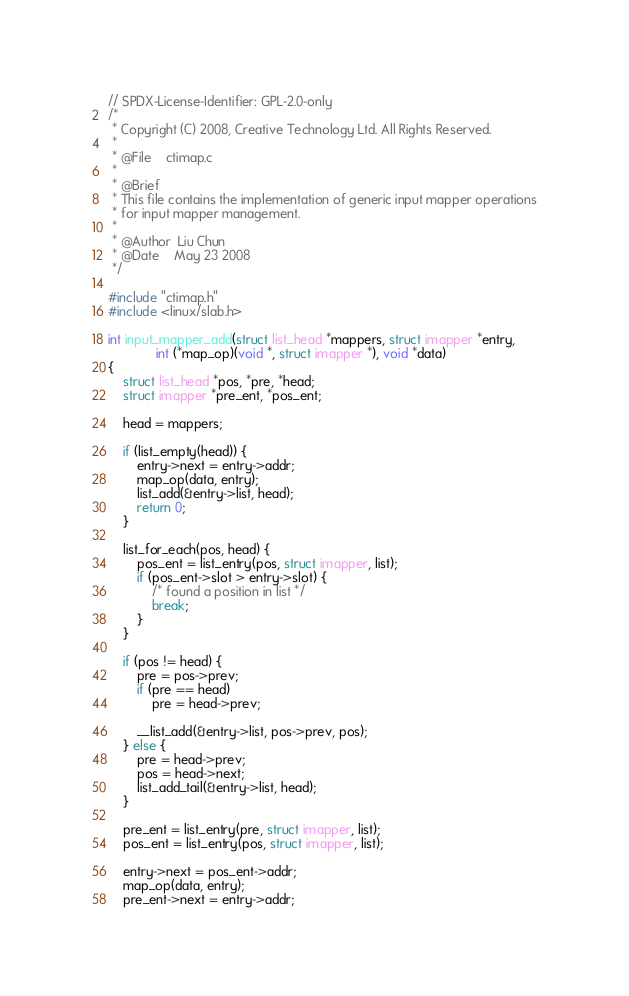Convert code to text. <code><loc_0><loc_0><loc_500><loc_500><_C_>// SPDX-License-Identifier: GPL-2.0-only
/*
 * Copyright (C) 2008, Creative Technology Ltd. All Rights Reserved.
 *
 * @File	ctimap.c
 *
 * @Brief
 * This file contains the implementation of generic input mapper operations
 * for input mapper management.
 *
 * @Author	Liu Chun
 * @Date 	May 23 2008
 */

#include "ctimap.h"
#include <linux/slab.h>

int input_mapper_add(struct list_head *mappers, struct imapper *entry,
		     int (*map_op)(void *, struct imapper *), void *data)
{
	struct list_head *pos, *pre, *head;
	struct imapper *pre_ent, *pos_ent;

	head = mappers;

	if (list_empty(head)) {
		entry->next = entry->addr;
		map_op(data, entry);
		list_add(&entry->list, head);
		return 0;
	}

	list_for_each(pos, head) {
		pos_ent = list_entry(pos, struct imapper, list);
		if (pos_ent->slot > entry->slot) {
			/* found a position in list */
			break;
		}
	}

	if (pos != head) {
		pre = pos->prev;
		if (pre == head)
			pre = head->prev;

		__list_add(&entry->list, pos->prev, pos);
	} else {
		pre = head->prev;
		pos = head->next;
		list_add_tail(&entry->list, head);
	}

	pre_ent = list_entry(pre, struct imapper, list);
	pos_ent = list_entry(pos, struct imapper, list);

	entry->next = pos_ent->addr;
	map_op(data, entry);
	pre_ent->next = entry->addr;</code> 